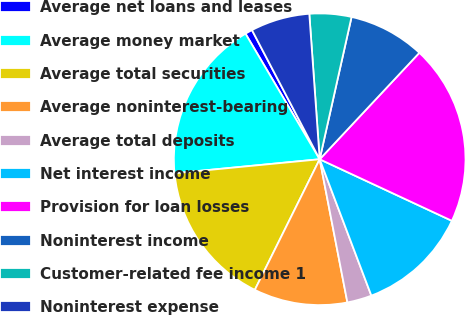Convert chart. <chart><loc_0><loc_0><loc_500><loc_500><pie_chart><fcel>Average net loans and leases<fcel>Average money market<fcel>Average total securities<fcel>Average noninterest-bearing<fcel>Average total deposits<fcel>Net interest income<fcel>Provision for loan losses<fcel>Noninterest income<fcel>Customer-related fee income 1<fcel>Noninterest expense<nl><fcel>0.81%<fcel>18.04%<fcel>16.13%<fcel>10.38%<fcel>2.72%<fcel>12.3%<fcel>19.96%<fcel>8.47%<fcel>4.64%<fcel>6.55%<nl></chart> 